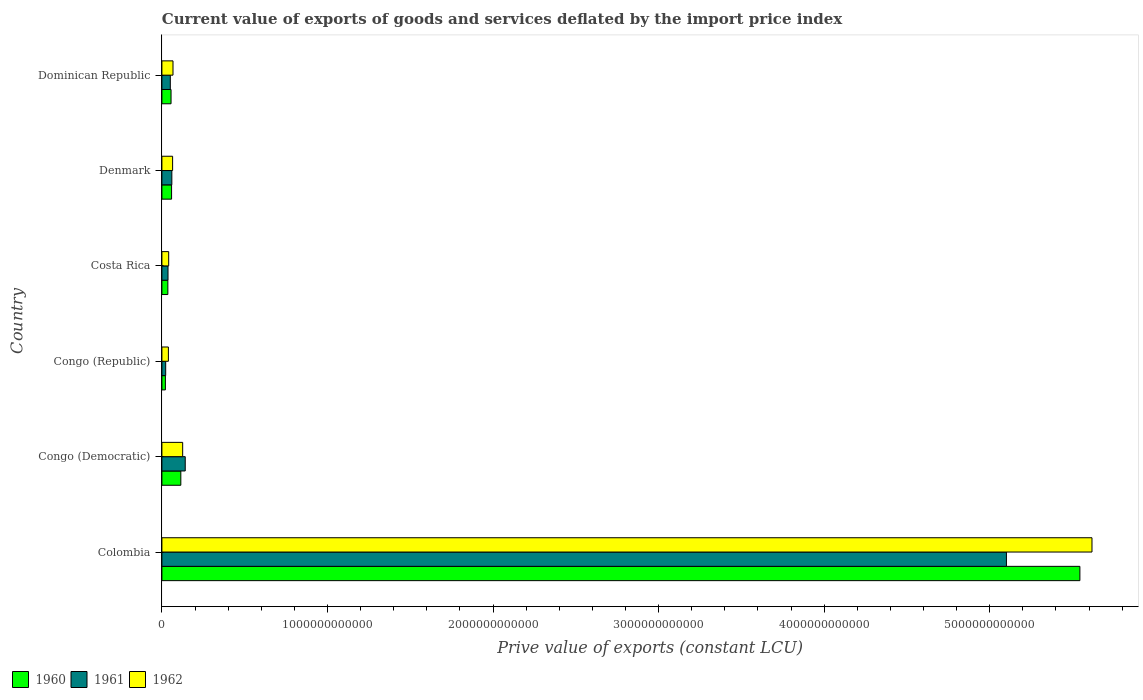Are the number of bars per tick equal to the number of legend labels?
Provide a short and direct response. Yes. Are the number of bars on each tick of the Y-axis equal?
Your response must be concise. Yes. What is the label of the 5th group of bars from the top?
Provide a short and direct response. Congo (Democratic). What is the prive value of exports in 1960 in Costa Rica?
Offer a terse response. 3.60e+1. Across all countries, what is the maximum prive value of exports in 1961?
Your response must be concise. 5.10e+12. Across all countries, what is the minimum prive value of exports in 1961?
Your answer should be very brief. 2.29e+1. In which country was the prive value of exports in 1961 minimum?
Ensure brevity in your answer.  Congo (Republic). What is the total prive value of exports in 1962 in the graph?
Make the answer very short. 5.95e+12. What is the difference between the prive value of exports in 1960 in Costa Rica and that in Dominican Republic?
Your answer should be compact. -1.93e+1. What is the difference between the prive value of exports in 1960 in Congo (Democratic) and the prive value of exports in 1961 in Dominican Republic?
Offer a very short reply. 6.35e+1. What is the average prive value of exports in 1962 per country?
Provide a short and direct response. 9.92e+11. What is the difference between the prive value of exports in 1962 and prive value of exports in 1960 in Colombia?
Your response must be concise. 7.31e+1. In how many countries, is the prive value of exports in 1962 greater than 3800000000000 LCU?
Give a very brief answer. 1. What is the ratio of the prive value of exports in 1962 in Colombia to that in Congo (Republic)?
Ensure brevity in your answer.  143.22. What is the difference between the highest and the second highest prive value of exports in 1961?
Provide a short and direct response. 4.96e+12. What is the difference between the highest and the lowest prive value of exports in 1960?
Keep it short and to the point. 5.52e+12. In how many countries, is the prive value of exports in 1961 greater than the average prive value of exports in 1961 taken over all countries?
Offer a terse response. 1. How many bars are there?
Provide a succinct answer. 18. Are all the bars in the graph horizontal?
Keep it short and to the point. Yes. How many countries are there in the graph?
Offer a terse response. 6. What is the difference between two consecutive major ticks on the X-axis?
Keep it short and to the point. 1.00e+12. Does the graph contain any zero values?
Offer a terse response. No. How are the legend labels stacked?
Your response must be concise. Horizontal. What is the title of the graph?
Make the answer very short. Current value of exports of goods and services deflated by the import price index. Does "1978" appear as one of the legend labels in the graph?
Your answer should be compact. No. What is the label or title of the X-axis?
Your response must be concise. Prive value of exports (constant LCU). What is the Prive value of exports (constant LCU) in 1960 in Colombia?
Your answer should be very brief. 5.54e+12. What is the Prive value of exports (constant LCU) in 1961 in Colombia?
Keep it short and to the point. 5.10e+12. What is the Prive value of exports (constant LCU) of 1962 in Colombia?
Provide a short and direct response. 5.62e+12. What is the Prive value of exports (constant LCU) in 1960 in Congo (Democratic)?
Make the answer very short. 1.14e+11. What is the Prive value of exports (constant LCU) in 1961 in Congo (Democratic)?
Ensure brevity in your answer.  1.41e+11. What is the Prive value of exports (constant LCU) of 1962 in Congo (Democratic)?
Give a very brief answer. 1.25e+11. What is the Prive value of exports (constant LCU) in 1960 in Congo (Republic)?
Your answer should be very brief. 2.11e+1. What is the Prive value of exports (constant LCU) of 1961 in Congo (Republic)?
Provide a succinct answer. 2.29e+1. What is the Prive value of exports (constant LCU) in 1962 in Congo (Republic)?
Keep it short and to the point. 3.92e+1. What is the Prive value of exports (constant LCU) in 1960 in Costa Rica?
Offer a terse response. 3.60e+1. What is the Prive value of exports (constant LCU) of 1961 in Costa Rica?
Provide a succinct answer. 3.69e+1. What is the Prive value of exports (constant LCU) in 1962 in Costa Rica?
Provide a short and direct response. 4.10e+1. What is the Prive value of exports (constant LCU) in 1960 in Denmark?
Your answer should be very brief. 5.84e+1. What is the Prive value of exports (constant LCU) in 1961 in Denmark?
Make the answer very short. 6.01e+1. What is the Prive value of exports (constant LCU) in 1962 in Denmark?
Make the answer very short. 6.47e+1. What is the Prive value of exports (constant LCU) in 1960 in Dominican Republic?
Make the answer very short. 5.53e+1. What is the Prive value of exports (constant LCU) in 1961 in Dominican Republic?
Provide a succinct answer. 5.08e+1. What is the Prive value of exports (constant LCU) in 1962 in Dominican Republic?
Provide a succinct answer. 6.70e+1. Across all countries, what is the maximum Prive value of exports (constant LCU) of 1960?
Keep it short and to the point. 5.54e+12. Across all countries, what is the maximum Prive value of exports (constant LCU) in 1961?
Give a very brief answer. 5.10e+12. Across all countries, what is the maximum Prive value of exports (constant LCU) in 1962?
Provide a succinct answer. 5.62e+12. Across all countries, what is the minimum Prive value of exports (constant LCU) of 1960?
Provide a succinct answer. 2.11e+1. Across all countries, what is the minimum Prive value of exports (constant LCU) of 1961?
Your answer should be very brief. 2.29e+1. Across all countries, what is the minimum Prive value of exports (constant LCU) in 1962?
Your response must be concise. 3.92e+1. What is the total Prive value of exports (constant LCU) of 1960 in the graph?
Provide a short and direct response. 5.83e+12. What is the total Prive value of exports (constant LCU) in 1961 in the graph?
Give a very brief answer. 5.41e+12. What is the total Prive value of exports (constant LCU) in 1962 in the graph?
Make the answer very short. 5.95e+12. What is the difference between the Prive value of exports (constant LCU) of 1960 in Colombia and that in Congo (Democratic)?
Your answer should be very brief. 5.43e+12. What is the difference between the Prive value of exports (constant LCU) of 1961 in Colombia and that in Congo (Democratic)?
Give a very brief answer. 4.96e+12. What is the difference between the Prive value of exports (constant LCU) in 1962 in Colombia and that in Congo (Democratic)?
Provide a short and direct response. 5.49e+12. What is the difference between the Prive value of exports (constant LCU) of 1960 in Colombia and that in Congo (Republic)?
Give a very brief answer. 5.52e+12. What is the difference between the Prive value of exports (constant LCU) in 1961 in Colombia and that in Congo (Republic)?
Give a very brief answer. 5.08e+12. What is the difference between the Prive value of exports (constant LCU) of 1962 in Colombia and that in Congo (Republic)?
Provide a short and direct response. 5.58e+12. What is the difference between the Prive value of exports (constant LCU) in 1960 in Colombia and that in Costa Rica?
Provide a succinct answer. 5.51e+12. What is the difference between the Prive value of exports (constant LCU) in 1961 in Colombia and that in Costa Rica?
Keep it short and to the point. 5.06e+12. What is the difference between the Prive value of exports (constant LCU) in 1962 in Colombia and that in Costa Rica?
Ensure brevity in your answer.  5.58e+12. What is the difference between the Prive value of exports (constant LCU) in 1960 in Colombia and that in Denmark?
Keep it short and to the point. 5.49e+12. What is the difference between the Prive value of exports (constant LCU) of 1961 in Colombia and that in Denmark?
Ensure brevity in your answer.  5.04e+12. What is the difference between the Prive value of exports (constant LCU) of 1962 in Colombia and that in Denmark?
Your response must be concise. 5.55e+12. What is the difference between the Prive value of exports (constant LCU) in 1960 in Colombia and that in Dominican Republic?
Provide a succinct answer. 5.49e+12. What is the difference between the Prive value of exports (constant LCU) in 1961 in Colombia and that in Dominican Republic?
Your answer should be compact. 5.05e+12. What is the difference between the Prive value of exports (constant LCU) in 1962 in Colombia and that in Dominican Republic?
Offer a very short reply. 5.55e+12. What is the difference between the Prive value of exports (constant LCU) of 1960 in Congo (Democratic) and that in Congo (Republic)?
Keep it short and to the point. 9.32e+1. What is the difference between the Prive value of exports (constant LCU) of 1961 in Congo (Democratic) and that in Congo (Republic)?
Provide a short and direct response. 1.18e+11. What is the difference between the Prive value of exports (constant LCU) of 1962 in Congo (Democratic) and that in Congo (Republic)?
Keep it short and to the point. 8.63e+1. What is the difference between the Prive value of exports (constant LCU) of 1960 in Congo (Democratic) and that in Costa Rica?
Provide a succinct answer. 7.83e+1. What is the difference between the Prive value of exports (constant LCU) of 1961 in Congo (Democratic) and that in Costa Rica?
Offer a terse response. 1.04e+11. What is the difference between the Prive value of exports (constant LCU) of 1962 in Congo (Democratic) and that in Costa Rica?
Ensure brevity in your answer.  8.45e+1. What is the difference between the Prive value of exports (constant LCU) of 1960 in Congo (Democratic) and that in Denmark?
Keep it short and to the point. 5.59e+1. What is the difference between the Prive value of exports (constant LCU) of 1961 in Congo (Democratic) and that in Denmark?
Provide a short and direct response. 8.08e+1. What is the difference between the Prive value of exports (constant LCU) of 1962 in Congo (Democratic) and that in Denmark?
Give a very brief answer. 6.08e+1. What is the difference between the Prive value of exports (constant LCU) in 1960 in Congo (Democratic) and that in Dominican Republic?
Give a very brief answer. 5.91e+1. What is the difference between the Prive value of exports (constant LCU) of 1961 in Congo (Democratic) and that in Dominican Republic?
Provide a short and direct response. 9.00e+1. What is the difference between the Prive value of exports (constant LCU) in 1962 in Congo (Democratic) and that in Dominican Republic?
Ensure brevity in your answer.  5.85e+1. What is the difference between the Prive value of exports (constant LCU) of 1960 in Congo (Republic) and that in Costa Rica?
Offer a terse response. -1.49e+1. What is the difference between the Prive value of exports (constant LCU) in 1961 in Congo (Republic) and that in Costa Rica?
Make the answer very short. -1.40e+1. What is the difference between the Prive value of exports (constant LCU) in 1962 in Congo (Republic) and that in Costa Rica?
Give a very brief answer. -1.77e+09. What is the difference between the Prive value of exports (constant LCU) of 1960 in Congo (Republic) and that in Denmark?
Provide a succinct answer. -3.73e+1. What is the difference between the Prive value of exports (constant LCU) of 1961 in Congo (Republic) and that in Denmark?
Keep it short and to the point. -3.72e+1. What is the difference between the Prive value of exports (constant LCU) in 1962 in Congo (Republic) and that in Denmark?
Keep it short and to the point. -2.55e+1. What is the difference between the Prive value of exports (constant LCU) in 1960 in Congo (Republic) and that in Dominican Republic?
Your answer should be compact. -3.42e+1. What is the difference between the Prive value of exports (constant LCU) of 1961 in Congo (Republic) and that in Dominican Republic?
Keep it short and to the point. -2.80e+1. What is the difference between the Prive value of exports (constant LCU) of 1962 in Congo (Republic) and that in Dominican Republic?
Your response must be concise. -2.78e+1. What is the difference between the Prive value of exports (constant LCU) of 1960 in Costa Rica and that in Denmark?
Offer a terse response. -2.24e+1. What is the difference between the Prive value of exports (constant LCU) in 1961 in Costa Rica and that in Denmark?
Offer a very short reply. -2.32e+1. What is the difference between the Prive value of exports (constant LCU) in 1962 in Costa Rica and that in Denmark?
Your response must be concise. -2.37e+1. What is the difference between the Prive value of exports (constant LCU) of 1960 in Costa Rica and that in Dominican Republic?
Give a very brief answer. -1.93e+1. What is the difference between the Prive value of exports (constant LCU) of 1961 in Costa Rica and that in Dominican Republic?
Provide a succinct answer. -1.39e+1. What is the difference between the Prive value of exports (constant LCU) of 1962 in Costa Rica and that in Dominican Republic?
Provide a short and direct response. -2.60e+1. What is the difference between the Prive value of exports (constant LCU) in 1960 in Denmark and that in Dominican Republic?
Give a very brief answer. 3.13e+09. What is the difference between the Prive value of exports (constant LCU) in 1961 in Denmark and that in Dominican Republic?
Provide a succinct answer. 9.26e+09. What is the difference between the Prive value of exports (constant LCU) in 1962 in Denmark and that in Dominican Republic?
Give a very brief answer. -2.35e+09. What is the difference between the Prive value of exports (constant LCU) in 1960 in Colombia and the Prive value of exports (constant LCU) in 1961 in Congo (Democratic)?
Your answer should be very brief. 5.40e+12. What is the difference between the Prive value of exports (constant LCU) in 1960 in Colombia and the Prive value of exports (constant LCU) in 1962 in Congo (Democratic)?
Offer a terse response. 5.42e+12. What is the difference between the Prive value of exports (constant LCU) in 1961 in Colombia and the Prive value of exports (constant LCU) in 1962 in Congo (Democratic)?
Offer a very short reply. 4.98e+12. What is the difference between the Prive value of exports (constant LCU) in 1960 in Colombia and the Prive value of exports (constant LCU) in 1961 in Congo (Republic)?
Provide a succinct answer. 5.52e+12. What is the difference between the Prive value of exports (constant LCU) of 1960 in Colombia and the Prive value of exports (constant LCU) of 1962 in Congo (Republic)?
Ensure brevity in your answer.  5.51e+12. What is the difference between the Prive value of exports (constant LCU) in 1961 in Colombia and the Prive value of exports (constant LCU) in 1962 in Congo (Republic)?
Provide a short and direct response. 5.06e+12. What is the difference between the Prive value of exports (constant LCU) of 1960 in Colombia and the Prive value of exports (constant LCU) of 1961 in Costa Rica?
Provide a short and direct response. 5.51e+12. What is the difference between the Prive value of exports (constant LCU) of 1960 in Colombia and the Prive value of exports (constant LCU) of 1962 in Costa Rica?
Provide a short and direct response. 5.50e+12. What is the difference between the Prive value of exports (constant LCU) in 1961 in Colombia and the Prive value of exports (constant LCU) in 1962 in Costa Rica?
Provide a succinct answer. 5.06e+12. What is the difference between the Prive value of exports (constant LCU) of 1960 in Colombia and the Prive value of exports (constant LCU) of 1961 in Denmark?
Your response must be concise. 5.48e+12. What is the difference between the Prive value of exports (constant LCU) in 1960 in Colombia and the Prive value of exports (constant LCU) in 1962 in Denmark?
Offer a very short reply. 5.48e+12. What is the difference between the Prive value of exports (constant LCU) of 1961 in Colombia and the Prive value of exports (constant LCU) of 1962 in Denmark?
Provide a short and direct response. 5.04e+12. What is the difference between the Prive value of exports (constant LCU) of 1960 in Colombia and the Prive value of exports (constant LCU) of 1961 in Dominican Republic?
Your response must be concise. 5.49e+12. What is the difference between the Prive value of exports (constant LCU) of 1960 in Colombia and the Prive value of exports (constant LCU) of 1962 in Dominican Republic?
Give a very brief answer. 5.48e+12. What is the difference between the Prive value of exports (constant LCU) in 1961 in Colombia and the Prive value of exports (constant LCU) in 1962 in Dominican Republic?
Offer a terse response. 5.03e+12. What is the difference between the Prive value of exports (constant LCU) of 1960 in Congo (Democratic) and the Prive value of exports (constant LCU) of 1961 in Congo (Republic)?
Provide a short and direct response. 9.15e+1. What is the difference between the Prive value of exports (constant LCU) of 1960 in Congo (Democratic) and the Prive value of exports (constant LCU) of 1962 in Congo (Republic)?
Keep it short and to the point. 7.51e+1. What is the difference between the Prive value of exports (constant LCU) in 1961 in Congo (Democratic) and the Prive value of exports (constant LCU) in 1962 in Congo (Republic)?
Keep it short and to the point. 1.02e+11. What is the difference between the Prive value of exports (constant LCU) in 1960 in Congo (Democratic) and the Prive value of exports (constant LCU) in 1961 in Costa Rica?
Provide a succinct answer. 7.74e+1. What is the difference between the Prive value of exports (constant LCU) in 1960 in Congo (Democratic) and the Prive value of exports (constant LCU) in 1962 in Costa Rica?
Give a very brief answer. 7.33e+1. What is the difference between the Prive value of exports (constant LCU) of 1961 in Congo (Democratic) and the Prive value of exports (constant LCU) of 1962 in Costa Rica?
Make the answer very short. 9.99e+1. What is the difference between the Prive value of exports (constant LCU) in 1960 in Congo (Democratic) and the Prive value of exports (constant LCU) in 1961 in Denmark?
Give a very brief answer. 5.42e+1. What is the difference between the Prive value of exports (constant LCU) in 1960 in Congo (Democratic) and the Prive value of exports (constant LCU) in 1962 in Denmark?
Ensure brevity in your answer.  4.97e+1. What is the difference between the Prive value of exports (constant LCU) in 1961 in Congo (Democratic) and the Prive value of exports (constant LCU) in 1962 in Denmark?
Give a very brief answer. 7.62e+1. What is the difference between the Prive value of exports (constant LCU) in 1960 in Congo (Democratic) and the Prive value of exports (constant LCU) in 1961 in Dominican Republic?
Give a very brief answer. 6.35e+1. What is the difference between the Prive value of exports (constant LCU) in 1960 in Congo (Democratic) and the Prive value of exports (constant LCU) in 1962 in Dominican Republic?
Keep it short and to the point. 4.73e+1. What is the difference between the Prive value of exports (constant LCU) of 1961 in Congo (Democratic) and the Prive value of exports (constant LCU) of 1962 in Dominican Republic?
Your answer should be compact. 7.39e+1. What is the difference between the Prive value of exports (constant LCU) of 1960 in Congo (Republic) and the Prive value of exports (constant LCU) of 1961 in Costa Rica?
Your answer should be very brief. -1.58e+1. What is the difference between the Prive value of exports (constant LCU) of 1960 in Congo (Republic) and the Prive value of exports (constant LCU) of 1962 in Costa Rica?
Give a very brief answer. -1.99e+1. What is the difference between the Prive value of exports (constant LCU) in 1961 in Congo (Republic) and the Prive value of exports (constant LCU) in 1962 in Costa Rica?
Provide a succinct answer. -1.81e+1. What is the difference between the Prive value of exports (constant LCU) in 1960 in Congo (Republic) and the Prive value of exports (constant LCU) in 1961 in Denmark?
Ensure brevity in your answer.  -3.90e+1. What is the difference between the Prive value of exports (constant LCU) in 1960 in Congo (Republic) and the Prive value of exports (constant LCU) in 1962 in Denmark?
Offer a terse response. -4.36e+1. What is the difference between the Prive value of exports (constant LCU) of 1961 in Congo (Republic) and the Prive value of exports (constant LCU) of 1962 in Denmark?
Your answer should be very brief. -4.18e+1. What is the difference between the Prive value of exports (constant LCU) of 1960 in Congo (Republic) and the Prive value of exports (constant LCU) of 1961 in Dominican Republic?
Offer a very short reply. -2.97e+1. What is the difference between the Prive value of exports (constant LCU) of 1960 in Congo (Republic) and the Prive value of exports (constant LCU) of 1962 in Dominican Republic?
Ensure brevity in your answer.  -4.59e+1. What is the difference between the Prive value of exports (constant LCU) of 1961 in Congo (Republic) and the Prive value of exports (constant LCU) of 1962 in Dominican Republic?
Offer a terse response. -4.42e+1. What is the difference between the Prive value of exports (constant LCU) of 1960 in Costa Rica and the Prive value of exports (constant LCU) of 1961 in Denmark?
Offer a very short reply. -2.41e+1. What is the difference between the Prive value of exports (constant LCU) in 1960 in Costa Rica and the Prive value of exports (constant LCU) in 1962 in Denmark?
Make the answer very short. -2.87e+1. What is the difference between the Prive value of exports (constant LCU) of 1961 in Costa Rica and the Prive value of exports (constant LCU) of 1962 in Denmark?
Your answer should be compact. -2.78e+1. What is the difference between the Prive value of exports (constant LCU) of 1960 in Costa Rica and the Prive value of exports (constant LCU) of 1961 in Dominican Republic?
Provide a short and direct response. -1.48e+1. What is the difference between the Prive value of exports (constant LCU) of 1960 in Costa Rica and the Prive value of exports (constant LCU) of 1962 in Dominican Republic?
Ensure brevity in your answer.  -3.10e+1. What is the difference between the Prive value of exports (constant LCU) of 1961 in Costa Rica and the Prive value of exports (constant LCU) of 1962 in Dominican Republic?
Your answer should be very brief. -3.01e+1. What is the difference between the Prive value of exports (constant LCU) of 1960 in Denmark and the Prive value of exports (constant LCU) of 1961 in Dominican Republic?
Ensure brevity in your answer.  7.57e+09. What is the difference between the Prive value of exports (constant LCU) in 1960 in Denmark and the Prive value of exports (constant LCU) in 1962 in Dominican Republic?
Your answer should be very brief. -8.62e+09. What is the difference between the Prive value of exports (constant LCU) of 1961 in Denmark and the Prive value of exports (constant LCU) of 1962 in Dominican Republic?
Ensure brevity in your answer.  -6.93e+09. What is the average Prive value of exports (constant LCU) in 1960 per country?
Give a very brief answer. 9.72e+11. What is the average Prive value of exports (constant LCU) in 1961 per country?
Provide a succinct answer. 9.02e+11. What is the average Prive value of exports (constant LCU) of 1962 per country?
Provide a short and direct response. 9.92e+11. What is the difference between the Prive value of exports (constant LCU) of 1960 and Prive value of exports (constant LCU) of 1961 in Colombia?
Provide a succinct answer. 4.44e+11. What is the difference between the Prive value of exports (constant LCU) of 1960 and Prive value of exports (constant LCU) of 1962 in Colombia?
Give a very brief answer. -7.31e+1. What is the difference between the Prive value of exports (constant LCU) in 1961 and Prive value of exports (constant LCU) in 1962 in Colombia?
Offer a very short reply. -5.17e+11. What is the difference between the Prive value of exports (constant LCU) in 1960 and Prive value of exports (constant LCU) in 1961 in Congo (Democratic)?
Give a very brief answer. -2.65e+1. What is the difference between the Prive value of exports (constant LCU) of 1960 and Prive value of exports (constant LCU) of 1962 in Congo (Democratic)?
Your response must be concise. -1.11e+1. What is the difference between the Prive value of exports (constant LCU) of 1961 and Prive value of exports (constant LCU) of 1962 in Congo (Democratic)?
Your response must be concise. 1.54e+1. What is the difference between the Prive value of exports (constant LCU) of 1960 and Prive value of exports (constant LCU) of 1961 in Congo (Republic)?
Offer a very short reply. -1.75e+09. What is the difference between the Prive value of exports (constant LCU) in 1960 and Prive value of exports (constant LCU) in 1962 in Congo (Republic)?
Provide a succinct answer. -1.81e+1. What is the difference between the Prive value of exports (constant LCU) of 1961 and Prive value of exports (constant LCU) of 1962 in Congo (Republic)?
Your answer should be compact. -1.64e+1. What is the difference between the Prive value of exports (constant LCU) of 1960 and Prive value of exports (constant LCU) of 1961 in Costa Rica?
Ensure brevity in your answer.  -8.99e+08. What is the difference between the Prive value of exports (constant LCU) of 1960 and Prive value of exports (constant LCU) of 1962 in Costa Rica?
Offer a terse response. -4.99e+09. What is the difference between the Prive value of exports (constant LCU) of 1961 and Prive value of exports (constant LCU) of 1962 in Costa Rica?
Your response must be concise. -4.09e+09. What is the difference between the Prive value of exports (constant LCU) in 1960 and Prive value of exports (constant LCU) in 1961 in Denmark?
Offer a terse response. -1.70e+09. What is the difference between the Prive value of exports (constant LCU) in 1960 and Prive value of exports (constant LCU) in 1962 in Denmark?
Give a very brief answer. -6.28e+09. What is the difference between the Prive value of exports (constant LCU) of 1961 and Prive value of exports (constant LCU) of 1962 in Denmark?
Make the answer very short. -4.58e+09. What is the difference between the Prive value of exports (constant LCU) of 1960 and Prive value of exports (constant LCU) of 1961 in Dominican Republic?
Offer a terse response. 4.43e+09. What is the difference between the Prive value of exports (constant LCU) of 1960 and Prive value of exports (constant LCU) of 1962 in Dominican Republic?
Your answer should be very brief. -1.18e+1. What is the difference between the Prive value of exports (constant LCU) in 1961 and Prive value of exports (constant LCU) in 1962 in Dominican Republic?
Make the answer very short. -1.62e+1. What is the ratio of the Prive value of exports (constant LCU) of 1960 in Colombia to that in Congo (Democratic)?
Give a very brief answer. 48.49. What is the ratio of the Prive value of exports (constant LCU) of 1961 in Colombia to that in Congo (Democratic)?
Ensure brevity in your answer.  36.21. What is the ratio of the Prive value of exports (constant LCU) of 1962 in Colombia to that in Congo (Democratic)?
Ensure brevity in your answer.  44.77. What is the ratio of the Prive value of exports (constant LCU) of 1960 in Colombia to that in Congo (Republic)?
Provide a succinct answer. 262.67. What is the ratio of the Prive value of exports (constant LCU) in 1961 in Colombia to that in Congo (Republic)?
Give a very brief answer. 223.16. What is the ratio of the Prive value of exports (constant LCU) of 1962 in Colombia to that in Congo (Republic)?
Offer a very short reply. 143.22. What is the ratio of the Prive value of exports (constant LCU) of 1960 in Colombia to that in Costa Rica?
Offer a very short reply. 154.01. What is the ratio of the Prive value of exports (constant LCU) of 1961 in Colombia to that in Costa Rica?
Your answer should be compact. 138.23. What is the ratio of the Prive value of exports (constant LCU) in 1962 in Colombia to that in Costa Rica?
Offer a very short reply. 137.04. What is the ratio of the Prive value of exports (constant LCU) in 1960 in Colombia to that in Denmark?
Ensure brevity in your answer.  94.93. What is the ratio of the Prive value of exports (constant LCU) in 1961 in Colombia to that in Denmark?
Provide a short and direct response. 84.87. What is the ratio of the Prive value of exports (constant LCU) of 1962 in Colombia to that in Denmark?
Provide a succinct answer. 86.85. What is the ratio of the Prive value of exports (constant LCU) of 1960 in Colombia to that in Dominican Republic?
Keep it short and to the point. 100.32. What is the ratio of the Prive value of exports (constant LCU) of 1961 in Colombia to that in Dominican Republic?
Give a very brief answer. 100.33. What is the ratio of the Prive value of exports (constant LCU) of 1962 in Colombia to that in Dominican Republic?
Your response must be concise. 83.81. What is the ratio of the Prive value of exports (constant LCU) of 1960 in Congo (Democratic) to that in Congo (Republic)?
Ensure brevity in your answer.  5.42. What is the ratio of the Prive value of exports (constant LCU) of 1961 in Congo (Democratic) to that in Congo (Republic)?
Give a very brief answer. 6.16. What is the ratio of the Prive value of exports (constant LCU) in 1962 in Congo (Democratic) to that in Congo (Republic)?
Give a very brief answer. 3.2. What is the ratio of the Prive value of exports (constant LCU) in 1960 in Congo (Democratic) to that in Costa Rica?
Ensure brevity in your answer.  3.18. What is the ratio of the Prive value of exports (constant LCU) in 1961 in Congo (Democratic) to that in Costa Rica?
Your response must be concise. 3.82. What is the ratio of the Prive value of exports (constant LCU) in 1962 in Congo (Democratic) to that in Costa Rica?
Offer a very short reply. 3.06. What is the ratio of the Prive value of exports (constant LCU) of 1960 in Congo (Democratic) to that in Denmark?
Offer a very short reply. 1.96. What is the ratio of the Prive value of exports (constant LCU) in 1961 in Congo (Democratic) to that in Denmark?
Ensure brevity in your answer.  2.34. What is the ratio of the Prive value of exports (constant LCU) of 1962 in Congo (Democratic) to that in Denmark?
Give a very brief answer. 1.94. What is the ratio of the Prive value of exports (constant LCU) of 1960 in Congo (Democratic) to that in Dominican Republic?
Your response must be concise. 2.07. What is the ratio of the Prive value of exports (constant LCU) of 1961 in Congo (Democratic) to that in Dominican Republic?
Make the answer very short. 2.77. What is the ratio of the Prive value of exports (constant LCU) in 1962 in Congo (Democratic) to that in Dominican Republic?
Give a very brief answer. 1.87. What is the ratio of the Prive value of exports (constant LCU) in 1960 in Congo (Republic) to that in Costa Rica?
Offer a very short reply. 0.59. What is the ratio of the Prive value of exports (constant LCU) in 1961 in Congo (Republic) to that in Costa Rica?
Your answer should be very brief. 0.62. What is the ratio of the Prive value of exports (constant LCU) of 1962 in Congo (Republic) to that in Costa Rica?
Your response must be concise. 0.96. What is the ratio of the Prive value of exports (constant LCU) of 1960 in Congo (Republic) to that in Denmark?
Provide a succinct answer. 0.36. What is the ratio of the Prive value of exports (constant LCU) of 1961 in Congo (Republic) to that in Denmark?
Your answer should be very brief. 0.38. What is the ratio of the Prive value of exports (constant LCU) of 1962 in Congo (Republic) to that in Denmark?
Your answer should be compact. 0.61. What is the ratio of the Prive value of exports (constant LCU) of 1960 in Congo (Republic) to that in Dominican Republic?
Offer a terse response. 0.38. What is the ratio of the Prive value of exports (constant LCU) of 1961 in Congo (Republic) to that in Dominican Republic?
Your answer should be very brief. 0.45. What is the ratio of the Prive value of exports (constant LCU) in 1962 in Congo (Republic) to that in Dominican Republic?
Your response must be concise. 0.59. What is the ratio of the Prive value of exports (constant LCU) in 1960 in Costa Rica to that in Denmark?
Offer a very short reply. 0.62. What is the ratio of the Prive value of exports (constant LCU) in 1961 in Costa Rica to that in Denmark?
Provide a short and direct response. 0.61. What is the ratio of the Prive value of exports (constant LCU) of 1962 in Costa Rica to that in Denmark?
Offer a terse response. 0.63. What is the ratio of the Prive value of exports (constant LCU) of 1960 in Costa Rica to that in Dominican Republic?
Provide a short and direct response. 0.65. What is the ratio of the Prive value of exports (constant LCU) in 1961 in Costa Rica to that in Dominican Republic?
Give a very brief answer. 0.73. What is the ratio of the Prive value of exports (constant LCU) in 1962 in Costa Rica to that in Dominican Republic?
Provide a short and direct response. 0.61. What is the ratio of the Prive value of exports (constant LCU) of 1960 in Denmark to that in Dominican Republic?
Offer a terse response. 1.06. What is the ratio of the Prive value of exports (constant LCU) in 1961 in Denmark to that in Dominican Republic?
Make the answer very short. 1.18. What is the difference between the highest and the second highest Prive value of exports (constant LCU) of 1960?
Your response must be concise. 5.43e+12. What is the difference between the highest and the second highest Prive value of exports (constant LCU) in 1961?
Make the answer very short. 4.96e+12. What is the difference between the highest and the second highest Prive value of exports (constant LCU) in 1962?
Your answer should be compact. 5.49e+12. What is the difference between the highest and the lowest Prive value of exports (constant LCU) of 1960?
Your answer should be compact. 5.52e+12. What is the difference between the highest and the lowest Prive value of exports (constant LCU) of 1961?
Offer a very short reply. 5.08e+12. What is the difference between the highest and the lowest Prive value of exports (constant LCU) in 1962?
Make the answer very short. 5.58e+12. 